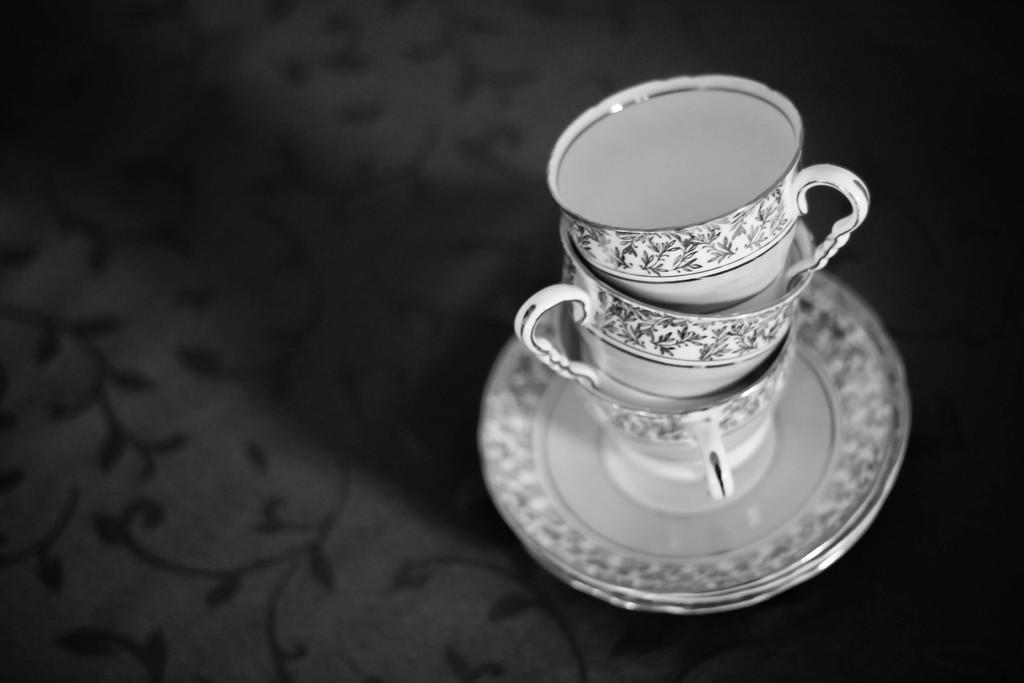What is the color scheme of the image? The image is black and white. What objects are on the plates in the image? There are cups on plates in the image. Where are the cups placed in the image? The cups are on a platform in the image. What can be seen on the platform besides the cups? There is a design on the platform. What type of plough can be seen in the image? There is no plough present in the image. Is there a garden visible in the image? There is no garden visible in the image. 